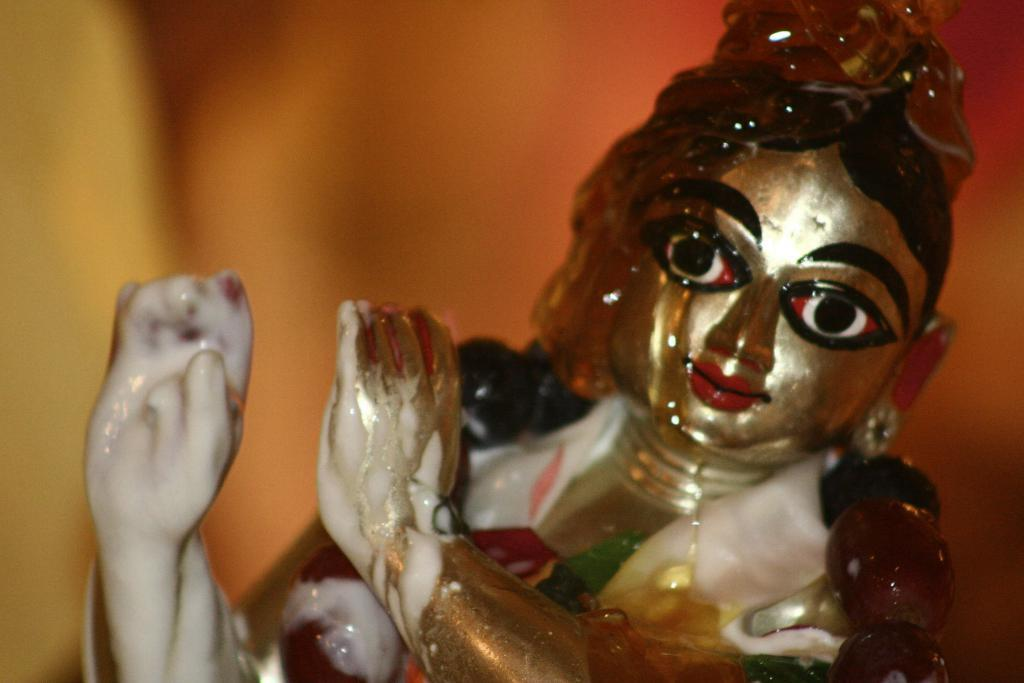What is the main subject of the image? There is an idol in the image. Can you describe the background of the image? The background of the image is blurred. What type of trade is happening in the image? There is no trade depicted in the image; it features an idol with a blurred background. Can you see any crooks in the image? There are no crooks or criminal activities depicted in the image; it features an idol with a blurred background. 